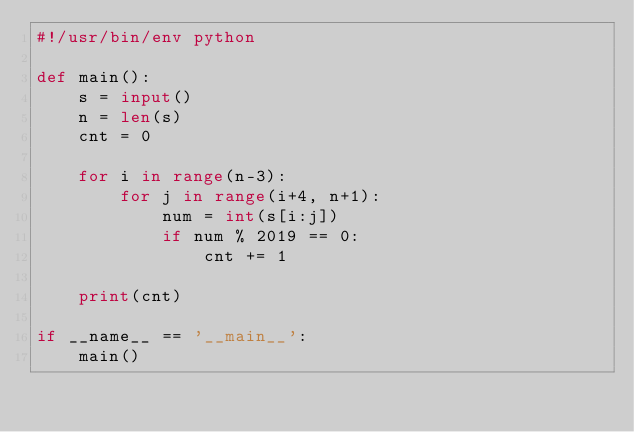<code> <loc_0><loc_0><loc_500><loc_500><_Python_>#!/usr/bin/env python

def main():
    s = input()
    n = len(s)
    cnt = 0

    for i in range(n-3):
        for j in range(i+4, n+1):
            num = int(s[i:j])
            if num % 2019 == 0:
                cnt += 1

    print(cnt)

if __name__ == '__main__':
    main()
</code> 